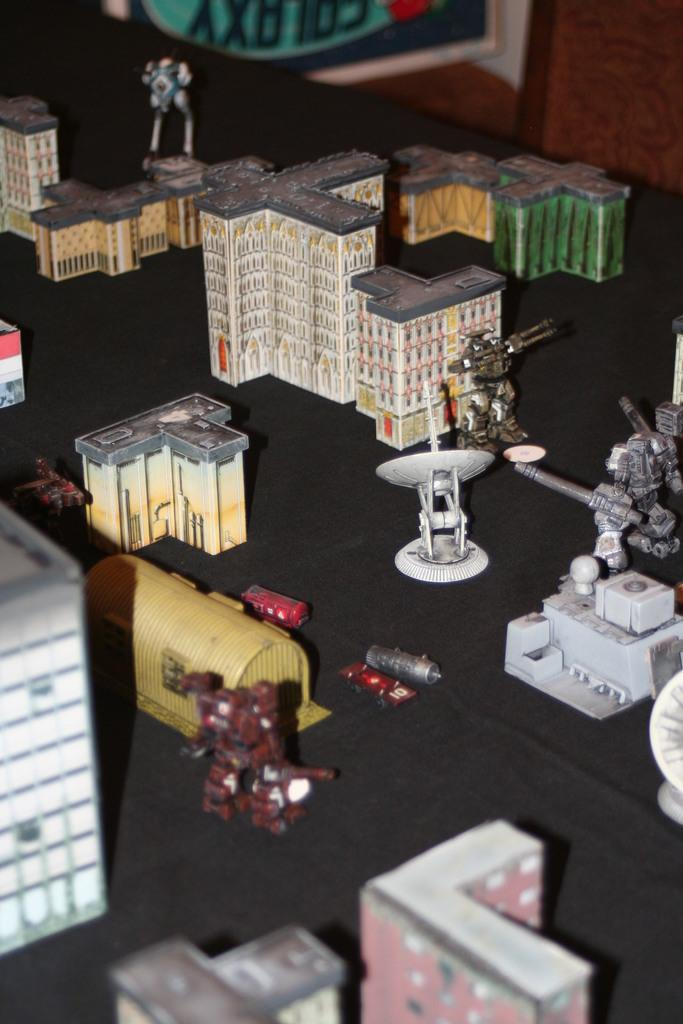What is the main subject of the image? The main subject of the image is a group of toys. Where are the toys located in the image? The toys are placed on a surface in the image. What else can be seen in the background of the image? There is a photo frame in the background of the image. What type of fang can be seen in the image? There is no fang present in the image; it features a group of toys placed on a surface with a photo frame in the background. 